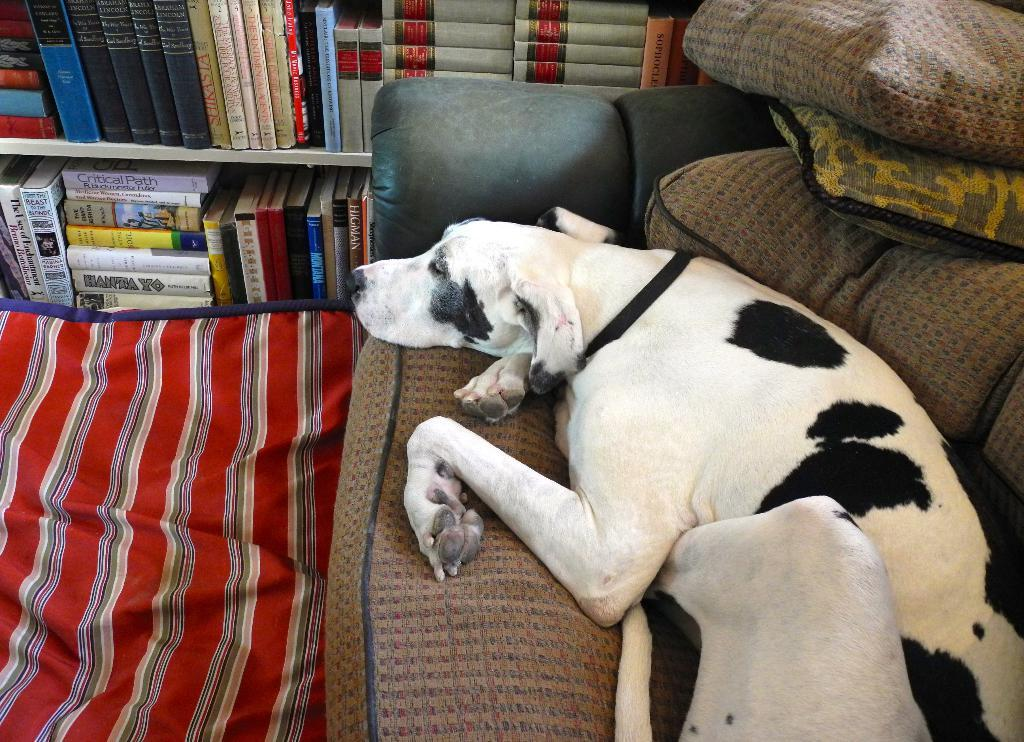What is the main subject of the image? There is a dog lying on the sofa in the image. What can be seen in the background of the image? In the background, there are cushions, books on a shelf, and a bed sheet. Can you describe the setting of the image? The image appears to be set in a living room or similar space, with a sofa, cushions, and a bookshelf. How many boats are visible in the image? There are no boats present in the image. What type of chain can be seen connecting the books on the shelf? There is no chain visible in the image; the books on the shelf are not connected by a chain. 